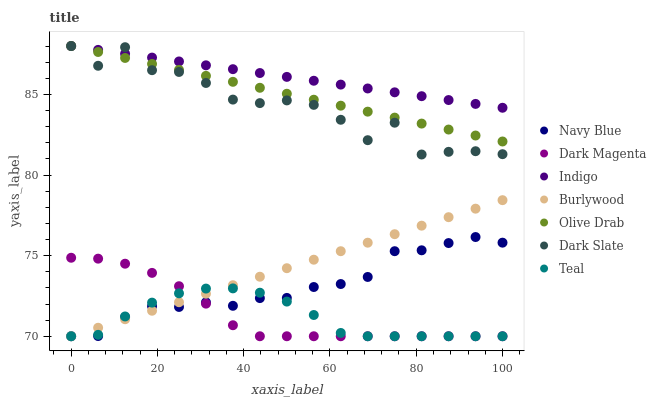Does Teal have the minimum area under the curve?
Answer yes or no. Yes. Does Indigo have the maximum area under the curve?
Answer yes or no. Yes. Does Dark Magenta have the minimum area under the curve?
Answer yes or no. No. Does Dark Magenta have the maximum area under the curve?
Answer yes or no. No. Is Burlywood the smoothest?
Answer yes or no. Yes. Is Dark Slate the roughest?
Answer yes or no. Yes. Is Dark Magenta the smoothest?
Answer yes or no. No. Is Dark Magenta the roughest?
Answer yes or no. No. Does Dark Magenta have the lowest value?
Answer yes or no. Yes. Does Dark Slate have the lowest value?
Answer yes or no. No. Does Olive Drab have the highest value?
Answer yes or no. Yes. Does Dark Magenta have the highest value?
Answer yes or no. No. Is Burlywood less than Dark Slate?
Answer yes or no. Yes. Is Dark Slate greater than Navy Blue?
Answer yes or no. Yes. Does Teal intersect Burlywood?
Answer yes or no. Yes. Is Teal less than Burlywood?
Answer yes or no. No. Is Teal greater than Burlywood?
Answer yes or no. No. Does Burlywood intersect Dark Slate?
Answer yes or no. No. 